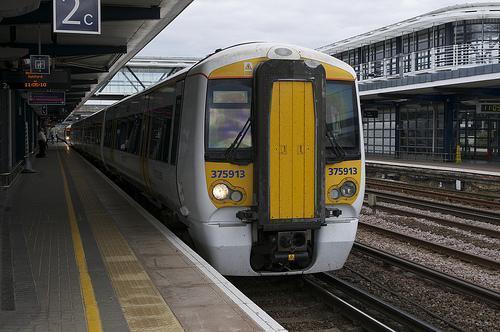How many trains are there?
Give a very brief answer. 1. 